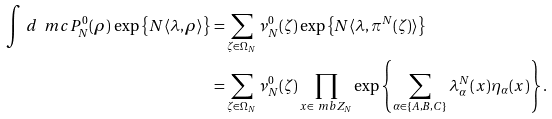<formula> <loc_0><loc_0><loc_500><loc_500>\int \, d \ m c P _ { N } ^ { 0 } ( \rho ) \, \exp \left \{ N \langle \lambda , \rho \rangle \right \} & = \sum _ { \zeta \in \Omega _ { N } } \nu ^ { 0 } _ { N } ( \zeta ) \exp \left \{ N \langle \lambda , \pi ^ { N } ( \zeta ) \rangle \right \} \\ & = \sum _ { \zeta \in \Omega _ { N } } \nu ^ { 0 } _ { N } ( \zeta ) \prod _ { x \in \ m b Z _ { N } } \exp \left \{ \sum _ { \alpha \in \{ A , B , C \} } \lambda ^ { N } _ { \alpha } ( x ) \eta _ { \alpha } ( x ) \right \} .</formula> 